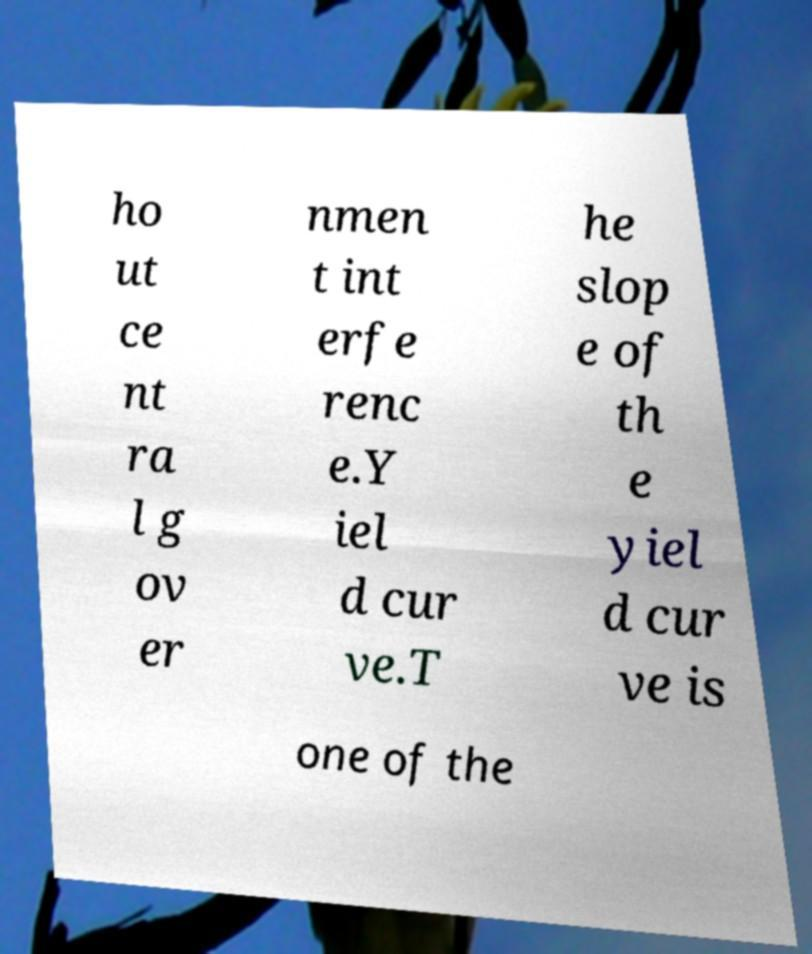I need the written content from this picture converted into text. Can you do that? ho ut ce nt ra l g ov er nmen t int erfe renc e.Y iel d cur ve.T he slop e of th e yiel d cur ve is one of the 